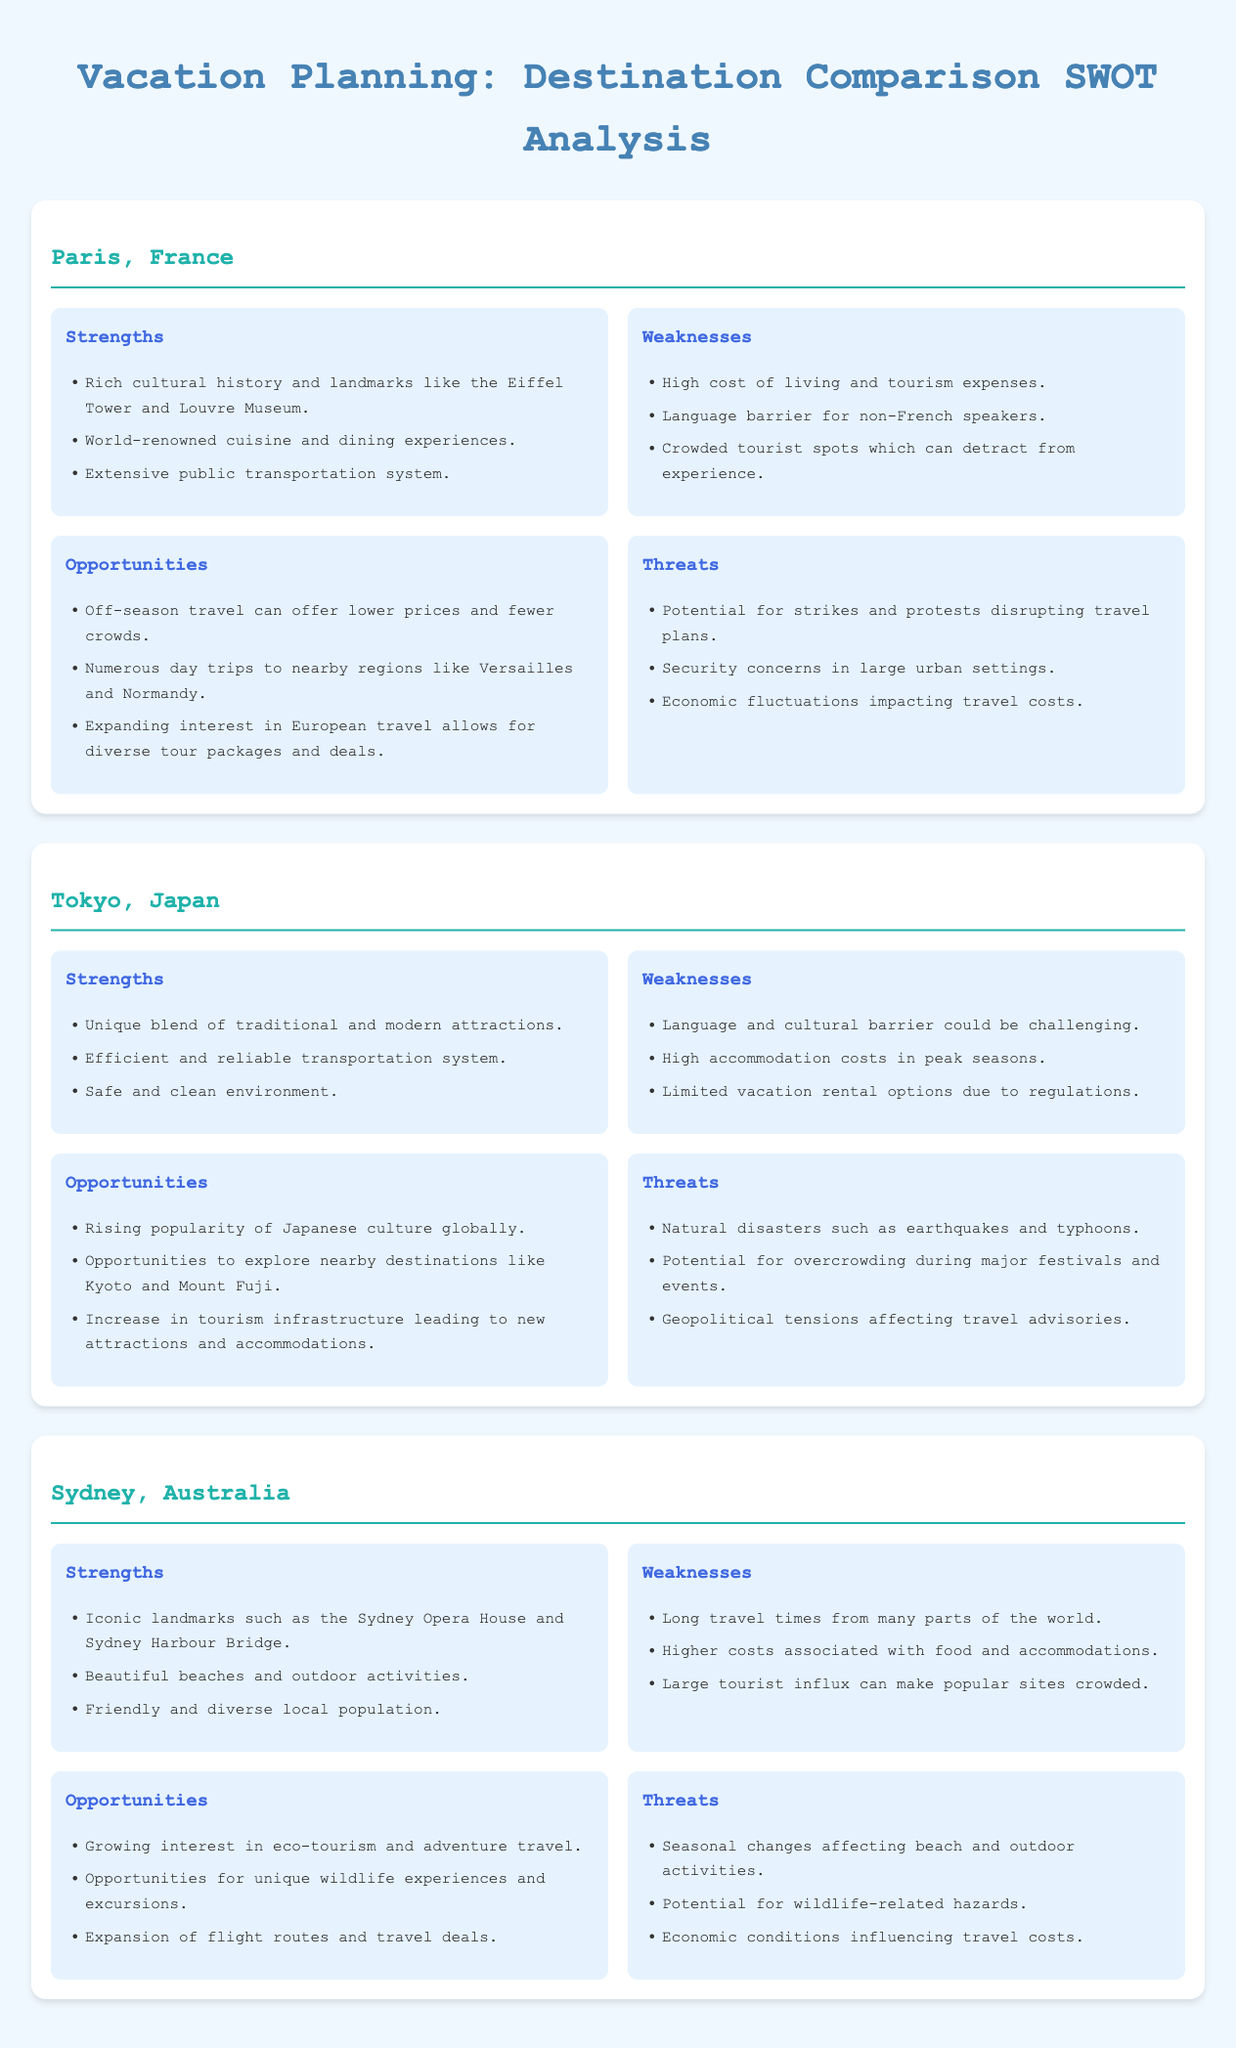What unique attraction is mentioned for Paris? The unique attraction is notable landmarks like the Eiffel Tower and Louvre Museum mentioned in the SWOT analysis.
Answer: Eiffel Tower and Louvre Museum What is a strength of Tokyo, Japan? One strength noted in the document is the efficient and reliable transportation system that Tokyo has.
Answer: Efficient and reliable transportation system What disadvantage does Sydney face according to the analysis? A weakness listed for Sydney is the long travel times from many parts of the world, which can impact travelers.
Answer: Long travel times What is one opportunity for Paris mentioned? One opportunity highlighted for Paris is off-season travel, which offers lower prices and fewer crowds.
Answer: Off-season travel Name one threat faced by Tokyo. The document mentions natural disasters such as earthquakes and typhoons as threats for Tokyo.
Answer: Natural disasters What type of experiences is Sydney noted for, according to opportunities? The analysis notes that Sydney offers opportunities for unique wildlife experiences and excursions.
Answer: Unique wildlife experiences Which destination is associated with cultural history? The document states that Paris, France is well-known for its rich cultural history, including famous landmarks.
Answer: Paris, France What is a shared weakness between the three destinations? A common weakness across the three destinations is the high costs associated with tourism.
Answer: High costs associated with tourism What is a significant security concern for Paris mentioned? The analysis points out security concerns in large urban settings as a threat for Paris.
Answer: Security concerns in large urban settings 